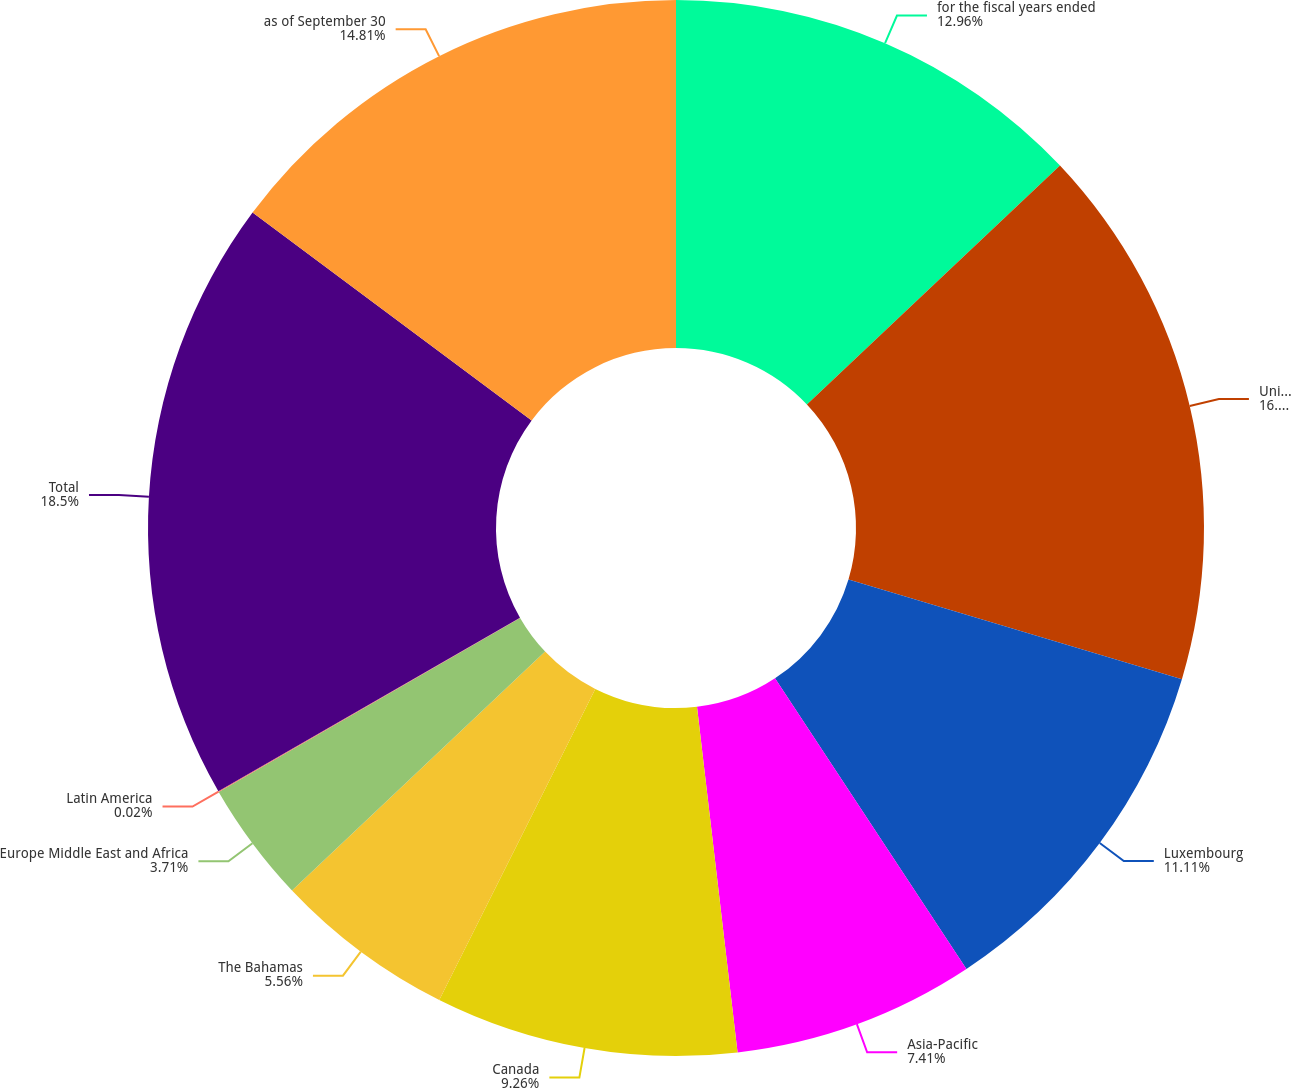Convert chart. <chart><loc_0><loc_0><loc_500><loc_500><pie_chart><fcel>for the fiscal years ended<fcel>United States<fcel>Luxembourg<fcel>Asia-Pacific<fcel>Canada<fcel>The Bahamas<fcel>Europe Middle East and Africa<fcel>Latin America<fcel>Total<fcel>as of September 30<nl><fcel>12.96%<fcel>16.66%<fcel>11.11%<fcel>7.41%<fcel>9.26%<fcel>5.56%<fcel>3.71%<fcel>0.02%<fcel>18.5%<fcel>14.81%<nl></chart> 